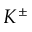Convert formula to latex. <formula><loc_0><loc_0><loc_500><loc_500>K ^ { \pm }</formula> 